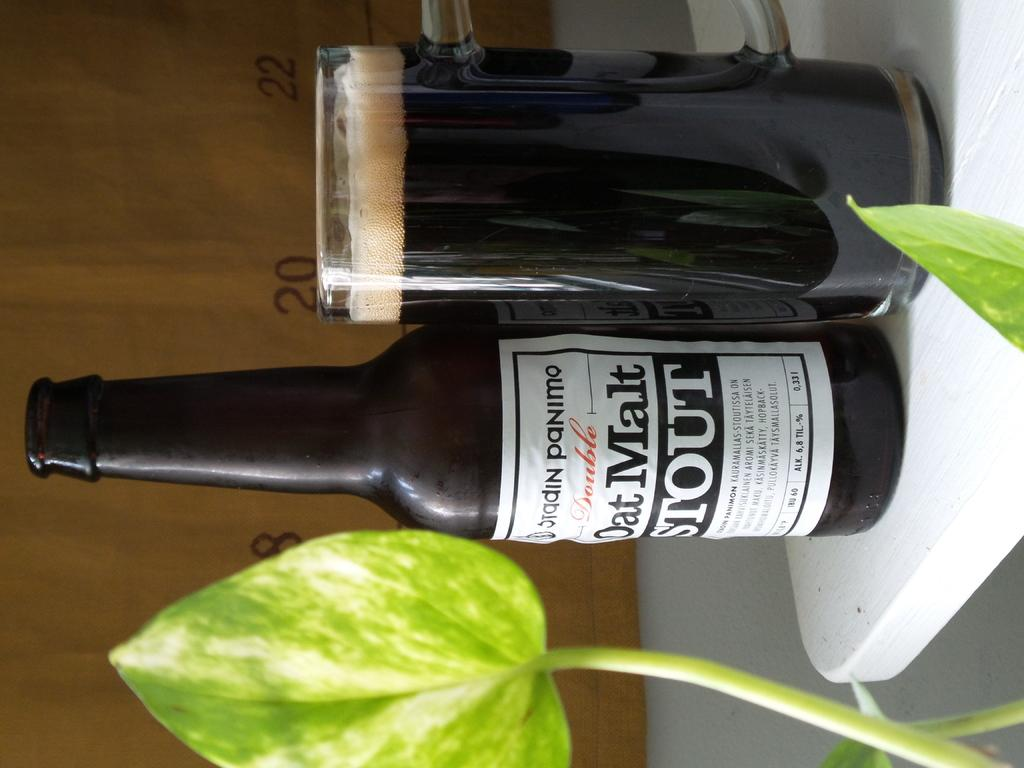<image>
Provide a brief description of the given image. A bottle of Oat Malt Stout sits next to a glass. 